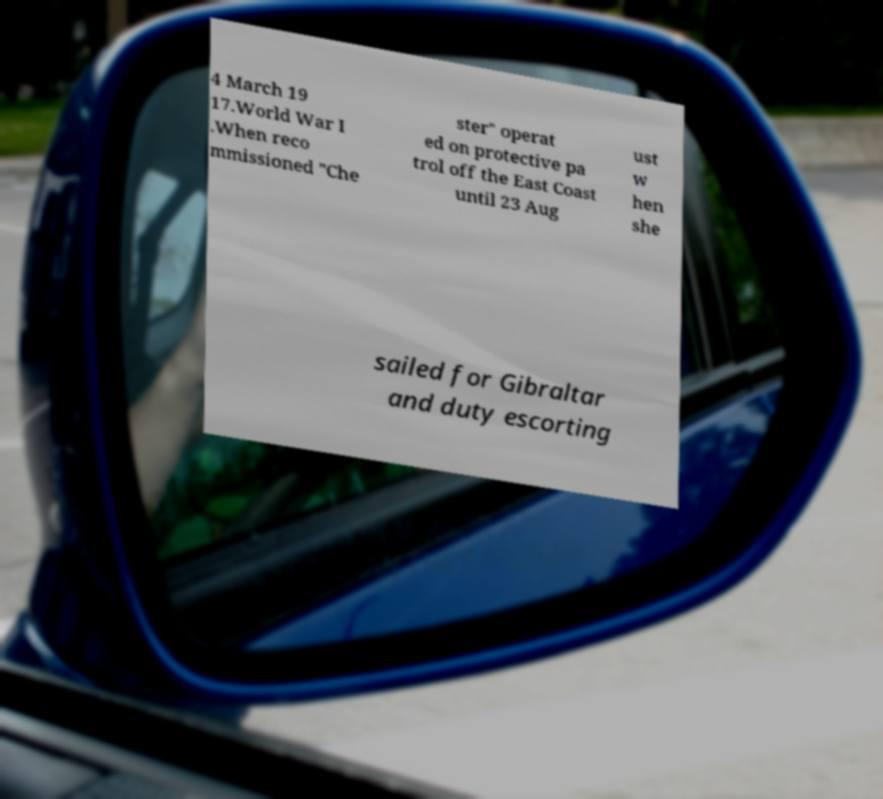Can you accurately transcribe the text from the provided image for me? 4 March 19 17.World War I .When reco mmissioned "Che ster" operat ed on protective pa trol off the East Coast until 23 Aug ust w hen she sailed for Gibraltar and duty escorting 